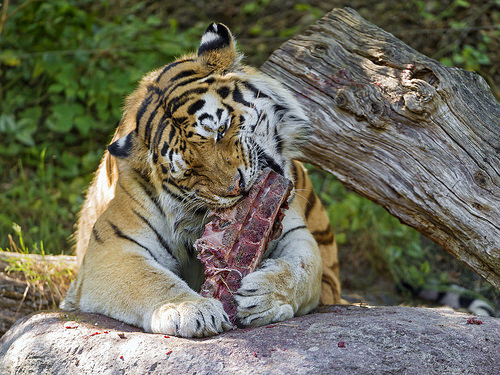<image>
Is there a tiger in front of the log? Yes. The tiger is positioned in front of the log, appearing closer to the camera viewpoint. 